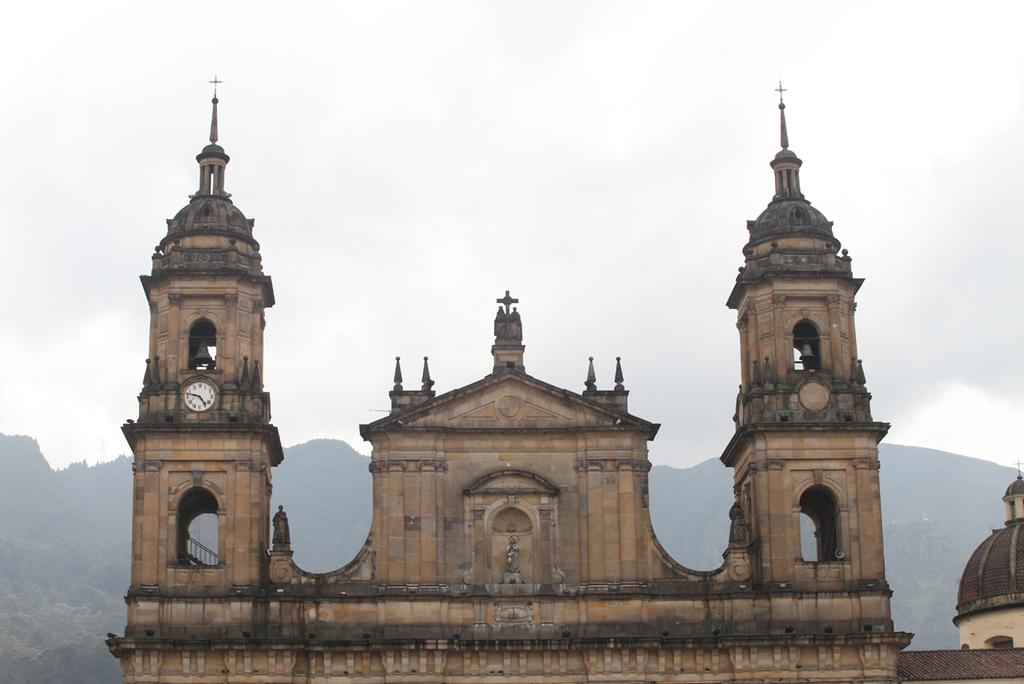What is the main subject of the picture? There is a monument in the picture. What other objects can be seen in the image? There is a wall clock in the picture. What can be seen in the background of the picture? Trees are visible in the background of the picture, and they are on a mountain. What is visible at the top of the image? The sky is visible at the top of the image, and clouds are present in the sky. Can you tell me how many kittens are playing in the alley in the image? There are no kittens or alley present in the image; it features a monument, a wall clock, trees on a mountain, and a sky with clouds. 